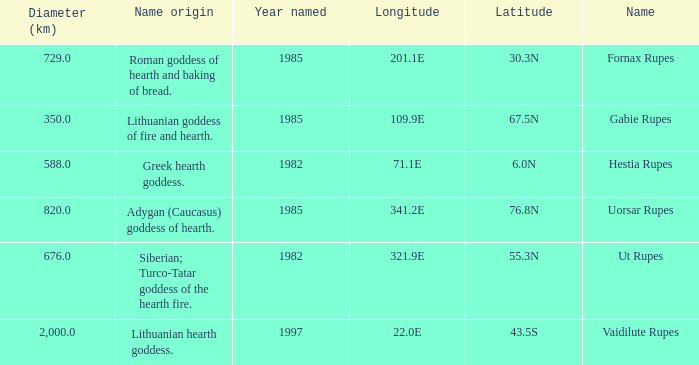At a longitude of 109.9e, how many features were found? 1.0. 